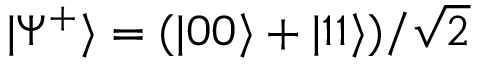Convert formula to latex. <formula><loc_0><loc_0><loc_500><loc_500>| \Psi ^ { + } \rangle = ( | 0 0 \rangle + | 1 1 \rangle ) / \sqrt { 2 }</formula> 